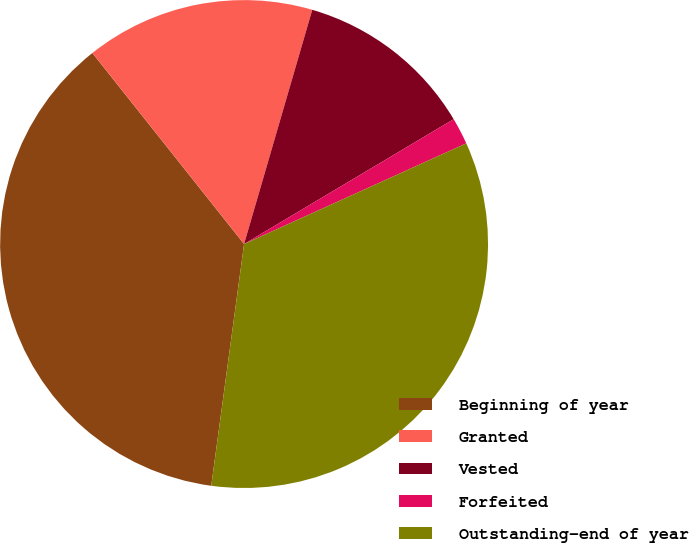Convert chart to OTSL. <chart><loc_0><loc_0><loc_500><loc_500><pie_chart><fcel>Beginning of year<fcel>Granted<fcel>Vested<fcel>Forfeited<fcel>Outstanding-end of year<nl><fcel>37.17%<fcel>15.19%<fcel>11.94%<fcel>1.78%<fcel>33.92%<nl></chart> 